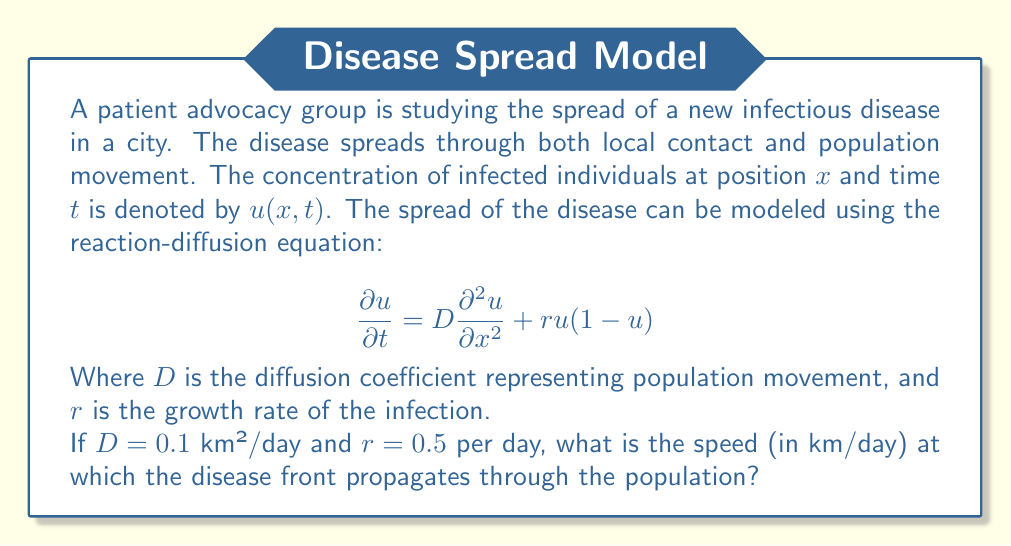Can you answer this question? To solve this problem, we need to use the formula for the speed of propagation in a reaction-diffusion equation, also known as the Fisher-KPP equation. The formula for the speed $c$ is:

$$c = 2\sqrt{rD}$$

where $r$ is the growth rate and $D$ is the diffusion coefficient.

Let's break down the solution step-by-step:

1) We are given:
   $D = 0.1$ km²/day
   $r = 0.5$ per day

2) Substituting these values into the formula:
   $$c = 2\sqrt{rD}$$
   $$c = 2\sqrt{(0.5)(0.1)}$$

3) Simplify inside the square root:
   $$c = 2\sqrt{0.05}$$

4) Calculate the square root:
   $$c = 2(0.2236)$$

5) Multiply:
   $$c = 0.4472$$ km/day

Therefore, the disease front propagates at a speed of approximately 0.4472 km/day.
Answer: 0.4472 km/day 